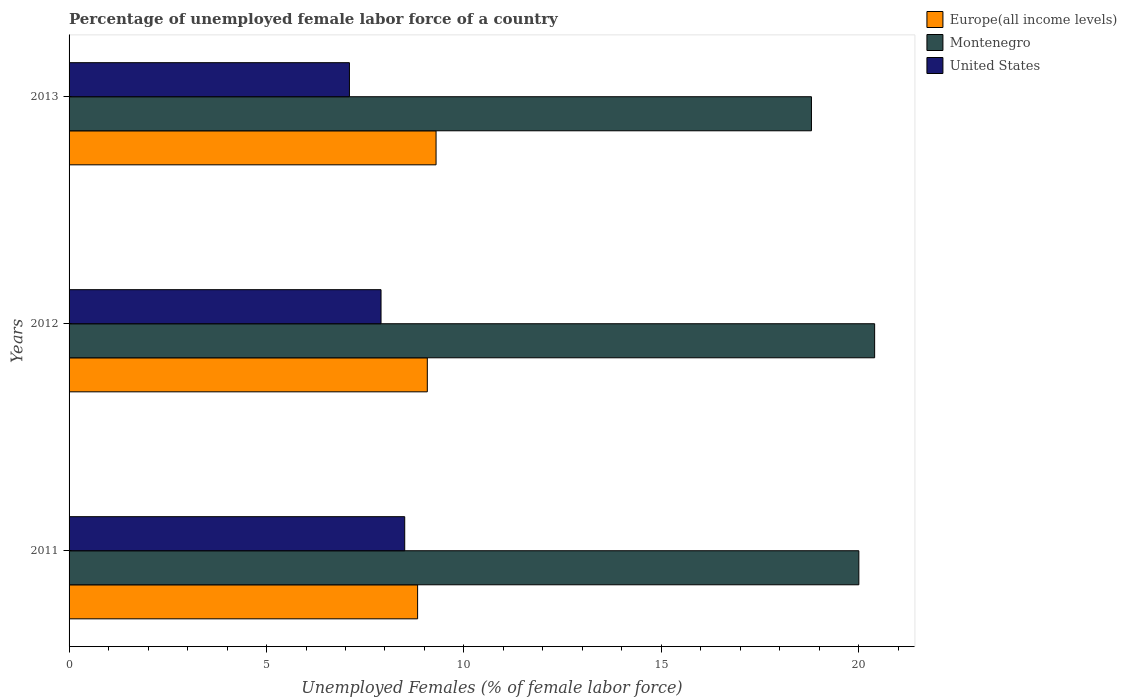How many groups of bars are there?
Give a very brief answer. 3. Are the number of bars on each tick of the Y-axis equal?
Offer a very short reply. Yes. How many bars are there on the 2nd tick from the top?
Your answer should be very brief. 3. How many bars are there on the 3rd tick from the bottom?
Your answer should be very brief. 3. What is the label of the 1st group of bars from the top?
Provide a short and direct response. 2013. What is the percentage of unemployed female labor force in United States in 2011?
Your answer should be compact. 8.5. Across all years, what is the minimum percentage of unemployed female labor force in United States?
Make the answer very short. 7.1. What is the total percentage of unemployed female labor force in United States in the graph?
Provide a short and direct response. 23.5. What is the difference between the percentage of unemployed female labor force in United States in 2012 and that in 2013?
Give a very brief answer. 0.8. What is the difference between the percentage of unemployed female labor force in Montenegro in 2011 and the percentage of unemployed female labor force in Europe(all income levels) in 2012?
Make the answer very short. 10.93. What is the average percentage of unemployed female labor force in Europe(all income levels) per year?
Provide a succinct answer. 9.06. In the year 2013, what is the difference between the percentage of unemployed female labor force in Montenegro and percentage of unemployed female labor force in Europe(all income levels)?
Offer a terse response. 9.51. What is the ratio of the percentage of unemployed female labor force in United States in 2012 to that in 2013?
Your response must be concise. 1.11. Is the difference between the percentage of unemployed female labor force in Montenegro in 2012 and 2013 greater than the difference between the percentage of unemployed female labor force in Europe(all income levels) in 2012 and 2013?
Give a very brief answer. Yes. What is the difference between the highest and the second highest percentage of unemployed female labor force in Europe(all income levels)?
Keep it short and to the point. 0.22. What is the difference between the highest and the lowest percentage of unemployed female labor force in Montenegro?
Offer a very short reply. 1.6. What does the 2nd bar from the top in 2011 represents?
Make the answer very short. Montenegro. What does the 1st bar from the bottom in 2012 represents?
Ensure brevity in your answer.  Europe(all income levels). Are all the bars in the graph horizontal?
Give a very brief answer. Yes. How many years are there in the graph?
Offer a terse response. 3. What is the difference between two consecutive major ticks on the X-axis?
Provide a succinct answer. 5. Does the graph contain any zero values?
Your answer should be very brief. No. How many legend labels are there?
Provide a succinct answer. 3. What is the title of the graph?
Offer a terse response. Percentage of unemployed female labor force of a country. Does "Grenada" appear as one of the legend labels in the graph?
Your answer should be very brief. No. What is the label or title of the X-axis?
Offer a terse response. Unemployed Females (% of female labor force). What is the label or title of the Y-axis?
Make the answer very short. Years. What is the Unemployed Females (% of female labor force) of Europe(all income levels) in 2011?
Offer a terse response. 8.83. What is the Unemployed Females (% of female labor force) of United States in 2011?
Offer a terse response. 8.5. What is the Unemployed Females (% of female labor force) in Europe(all income levels) in 2012?
Keep it short and to the point. 9.07. What is the Unemployed Females (% of female labor force) of Montenegro in 2012?
Provide a short and direct response. 20.4. What is the Unemployed Females (% of female labor force) in United States in 2012?
Offer a terse response. 7.9. What is the Unemployed Females (% of female labor force) in Europe(all income levels) in 2013?
Make the answer very short. 9.29. What is the Unemployed Females (% of female labor force) of Montenegro in 2013?
Your answer should be compact. 18.8. What is the Unemployed Females (% of female labor force) in United States in 2013?
Your response must be concise. 7.1. Across all years, what is the maximum Unemployed Females (% of female labor force) of Europe(all income levels)?
Provide a succinct answer. 9.29. Across all years, what is the maximum Unemployed Females (% of female labor force) in Montenegro?
Your answer should be very brief. 20.4. Across all years, what is the minimum Unemployed Females (% of female labor force) in Europe(all income levels)?
Provide a short and direct response. 8.83. Across all years, what is the minimum Unemployed Females (% of female labor force) in Montenegro?
Offer a terse response. 18.8. Across all years, what is the minimum Unemployed Females (% of female labor force) in United States?
Give a very brief answer. 7.1. What is the total Unemployed Females (% of female labor force) of Europe(all income levels) in the graph?
Your answer should be compact. 27.19. What is the total Unemployed Females (% of female labor force) of Montenegro in the graph?
Make the answer very short. 59.2. What is the total Unemployed Females (% of female labor force) of United States in the graph?
Ensure brevity in your answer.  23.5. What is the difference between the Unemployed Females (% of female labor force) in Europe(all income levels) in 2011 and that in 2012?
Ensure brevity in your answer.  -0.25. What is the difference between the Unemployed Females (% of female labor force) of United States in 2011 and that in 2012?
Provide a short and direct response. 0.6. What is the difference between the Unemployed Females (% of female labor force) in Europe(all income levels) in 2011 and that in 2013?
Provide a short and direct response. -0.47. What is the difference between the Unemployed Females (% of female labor force) of Montenegro in 2011 and that in 2013?
Give a very brief answer. 1.2. What is the difference between the Unemployed Females (% of female labor force) of United States in 2011 and that in 2013?
Your answer should be very brief. 1.4. What is the difference between the Unemployed Females (% of female labor force) of Europe(all income levels) in 2012 and that in 2013?
Ensure brevity in your answer.  -0.22. What is the difference between the Unemployed Females (% of female labor force) of Montenegro in 2012 and that in 2013?
Keep it short and to the point. 1.6. What is the difference between the Unemployed Females (% of female labor force) of United States in 2012 and that in 2013?
Offer a very short reply. 0.8. What is the difference between the Unemployed Females (% of female labor force) of Europe(all income levels) in 2011 and the Unemployed Females (% of female labor force) of Montenegro in 2012?
Your answer should be very brief. -11.57. What is the difference between the Unemployed Females (% of female labor force) of Europe(all income levels) in 2011 and the Unemployed Females (% of female labor force) of United States in 2012?
Your answer should be compact. 0.93. What is the difference between the Unemployed Females (% of female labor force) in Europe(all income levels) in 2011 and the Unemployed Females (% of female labor force) in Montenegro in 2013?
Provide a succinct answer. -9.97. What is the difference between the Unemployed Females (% of female labor force) of Europe(all income levels) in 2011 and the Unemployed Females (% of female labor force) of United States in 2013?
Offer a very short reply. 1.73. What is the difference between the Unemployed Females (% of female labor force) in Europe(all income levels) in 2012 and the Unemployed Females (% of female labor force) in Montenegro in 2013?
Offer a very short reply. -9.73. What is the difference between the Unemployed Females (% of female labor force) in Europe(all income levels) in 2012 and the Unemployed Females (% of female labor force) in United States in 2013?
Provide a short and direct response. 1.97. What is the difference between the Unemployed Females (% of female labor force) of Montenegro in 2012 and the Unemployed Females (% of female labor force) of United States in 2013?
Ensure brevity in your answer.  13.3. What is the average Unemployed Females (% of female labor force) in Europe(all income levels) per year?
Ensure brevity in your answer.  9.06. What is the average Unemployed Females (% of female labor force) of Montenegro per year?
Give a very brief answer. 19.73. What is the average Unemployed Females (% of female labor force) of United States per year?
Ensure brevity in your answer.  7.83. In the year 2011, what is the difference between the Unemployed Females (% of female labor force) of Europe(all income levels) and Unemployed Females (% of female labor force) of Montenegro?
Give a very brief answer. -11.17. In the year 2011, what is the difference between the Unemployed Females (% of female labor force) in Europe(all income levels) and Unemployed Females (% of female labor force) in United States?
Your response must be concise. 0.33. In the year 2011, what is the difference between the Unemployed Females (% of female labor force) in Montenegro and Unemployed Females (% of female labor force) in United States?
Offer a very short reply. 11.5. In the year 2012, what is the difference between the Unemployed Females (% of female labor force) in Europe(all income levels) and Unemployed Females (% of female labor force) in Montenegro?
Provide a short and direct response. -11.33. In the year 2012, what is the difference between the Unemployed Females (% of female labor force) in Europe(all income levels) and Unemployed Females (% of female labor force) in United States?
Keep it short and to the point. 1.17. In the year 2013, what is the difference between the Unemployed Females (% of female labor force) of Europe(all income levels) and Unemployed Females (% of female labor force) of Montenegro?
Provide a short and direct response. -9.51. In the year 2013, what is the difference between the Unemployed Females (% of female labor force) of Europe(all income levels) and Unemployed Females (% of female labor force) of United States?
Your answer should be very brief. 2.19. In the year 2013, what is the difference between the Unemployed Females (% of female labor force) of Montenegro and Unemployed Females (% of female labor force) of United States?
Your answer should be compact. 11.7. What is the ratio of the Unemployed Females (% of female labor force) in Europe(all income levels) in 2011 to that in 2012?
Provide a succinct answer. 0.97. What is the ratio of the Unemployed Females (% of female labor force) in Montenegro in 2011 to that in 2012?
Your answer should be very brief. 0.98. What is the ratio of the Unemployed Females (% of female labor force) of United States in 2011 to that in 2012?
Your answer should be very brief. 1.08. What is the ratio of the Unemployed Females (% of female labor force) of Europe(all income levels) in 2011 to that in 2013?
Offer a very short reply. 0.95. What is the ratio of the Unemployed Females (% of female labor force) in Montenegro in 2011 to that in 2013?
Your answer should be very brief. 1.06. What is the ratio of the Unemployed Females (% of female labor force) of United States in 2011 to that in 2013?
Ensure brevity in your answer.  1.2. What is the ratio of the Unemployed Females (% of female labor force) in Europe(all income levels) in 2012 to that in 2013?
Your response must be concise. 0.98. What is the ratio of the Unemployed Females (% of female labor force) of Montenegro in 2012 to that in 2013?
Make the answer very short. 1.09. What is the ratio of the Unemployed Females (% of female labor force) in United States in 2012 to that in 2013?
Keep it short and to the point. 1.11. What is the difference between the highest and the second highest Unemployed Females (% of female labor force) in Europe(all income levels)?
Keep it short and to the point. 0.22. What is the difference between the highest and the lowest Unemployed Females (% of female labor force) in Europe(all income levels)?
Offer a very short reply. 0.47. What is the difference between the highest and the lowest Unemployed Females (% of female labor force) in Montenegro?
Make the answer very short. 1.6. 